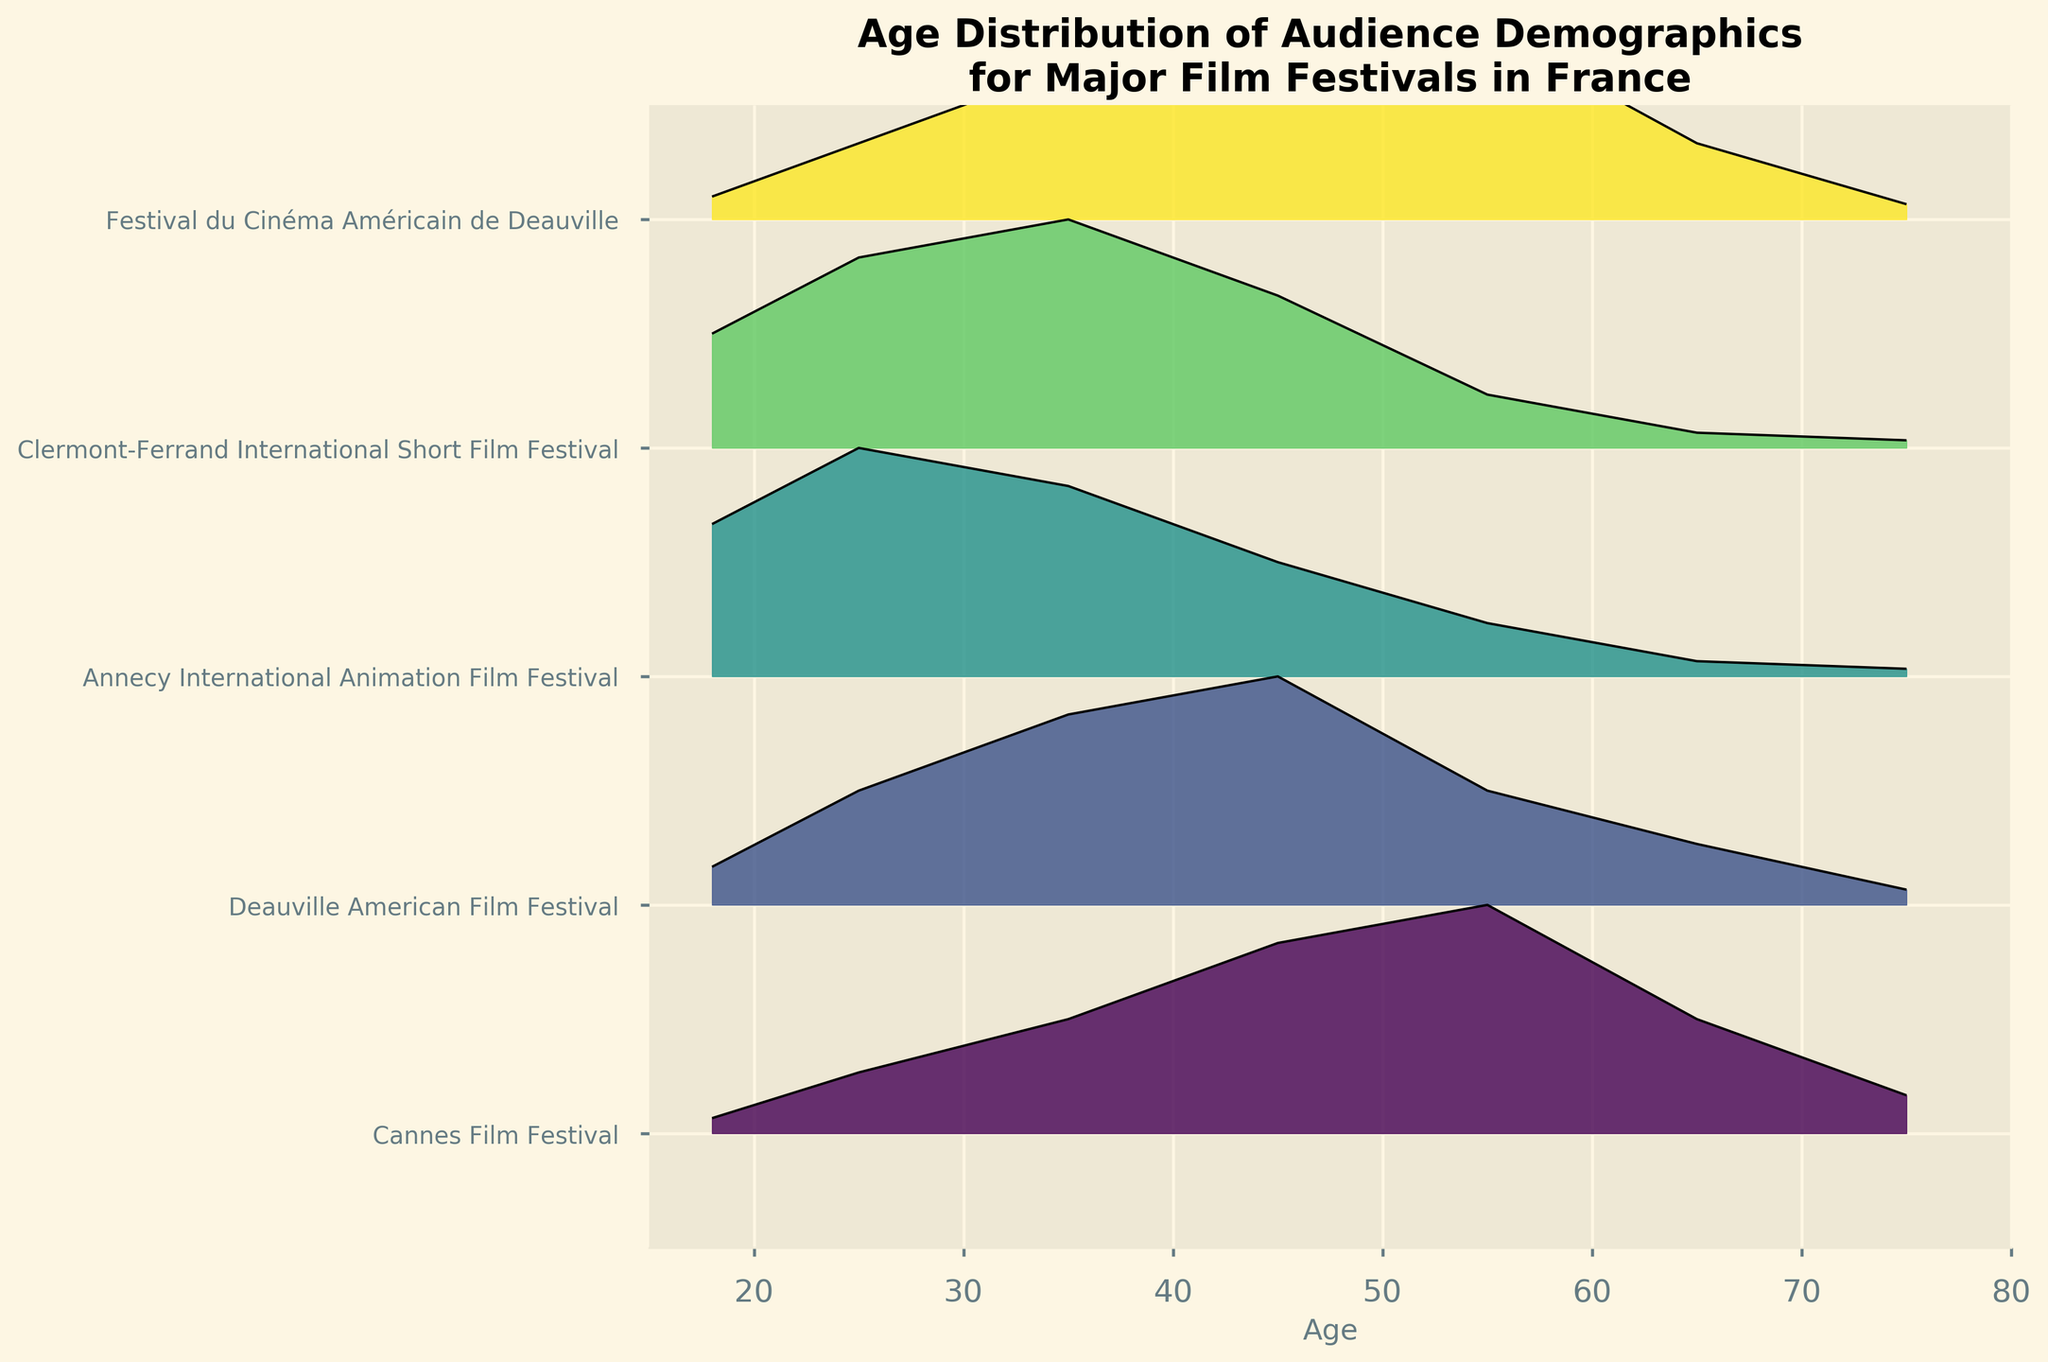What is the title of the plot? The title of the plot is checked at the top center of the figure.
Answer: Age Distribution of Audience Demographics for Major Film Festivals in France Which festival has the highest density for the age group 55? Look for the highest peak in the age group 55 across all festivals. For Cannes Film Festival, it peaks at 0.30, while Deauville American Film Festival peaks at 0.15. For Annecy International Animation Film Festival, it is 0.07, and Clermont-Ferrand International Short Film Festival is also 0.07. Finally, Festival du Cinéma Américain de Deauville peaks at 0.25.
Answer: Cannes Film Festival What is the general trend for the age distribution of Annecy International Animation Film Festival? For Annecy International Animation Film Festival, observe the pattern of density values as age increases. The graph starts high at age 18 (0.20), peaks at age 25 (0.30), and then gradually declines.
Answer: It peaks at age 25 and gradually declines Comparing the Clermont-Ferrand International Short Film Festival and the Cannes Film Festival, which one has a higher density for age 35? Identify the densities for age 35 for both festivals by looking at the corresponding lines. For Cannes Film Festival, the density is 0.15, whereas for Clermont-Ferrand International Short Film Festival, it is 0.30.
Answer: Clermont-Ferrand International Short Film Festival Which age group has the lowest density across all festivals? Observe each line to find the age with the smallest density value for each festival. The age group with consistently low densities across all festivals would be 75.
Answer: 75 How does the age distribution trend of Deauville American Film Festival compare to Festival du Cinéma Américain de Deauville? Compare the density lines for both festivals. For age 18, densities are 0.05 and 0.03 respectively. For age 25, 0.15 and 0.10. For age 35, 0.25 and 0.20. For age 45, both peak at 0.30. For age 55, the densities are 0.15 and 0.25. For age 65, 0.08 and 0.10. Finally, for age 75, being 0.02 for both.
Answer: Deauville American Film Festival has generally higher densities for younger age groups, while Festival du Cinéma Américain de Deauville has a higher density at age 55 What is the highest density value observed in the plot and for which age group and festival? Check all the peaks across all festivals and age groups. The highest peak is 0.30 observed at Cannes Film Festival for age 55 and at Annecy International Animation Film Festival for age 25.
Answer: 0.30, age 55 at Cannes Film Festival and age 25 at Annecy International Animation Film Festival Which festival has the broadest age range with higher densities? Observe the width of peaks for each festival across age groups. Clermont-Ferrand International Short Film Festival shows broader high-density values between ages 18 to 45. Cannes Film Festival shows density spread more in middle ages, and for Annecy, it is younger ages.
Answer: Clermont-Ferrand International Short Film Festival 